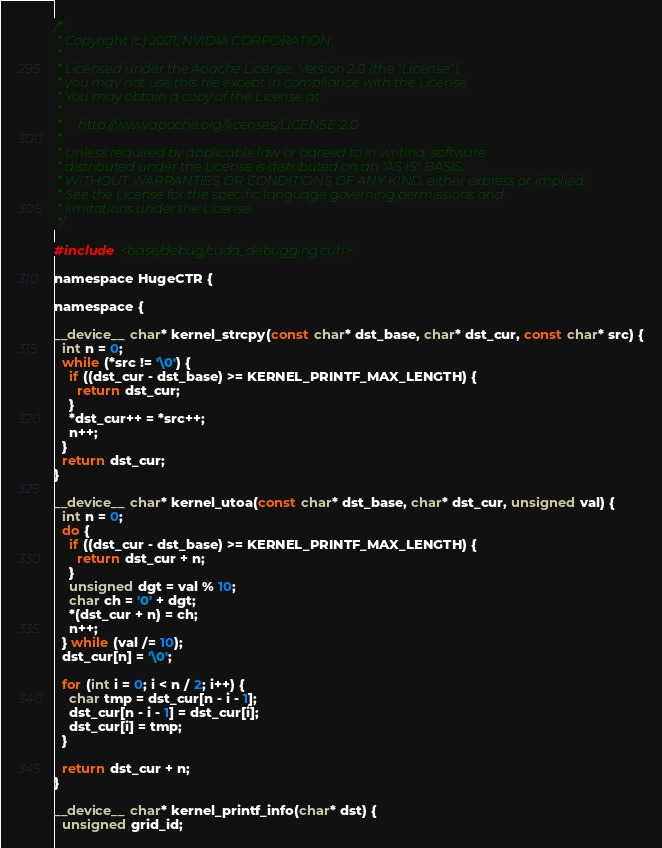Convert code to text. <code><loc_0><loc_0><loc_500><loc_500><_Cuda_>/*
 * Copyright (c) 2021, NVIDIA CORPORATION.
 *
 * Licensed under the Apache License, Version 2.0 (the "License");
 * you may not use this file except in compliance with the License.
 * You may obtain a copy of the License at
 *
 *     http://www.apache.org/licenses/LICENSE-2.0
 *
 * Unless required by applicable law or agreed to in writing, software
 * distributed under the License is distributed on an "AS IS" BASIS,
 * WITHOUT WARRANTIES OR CONDITIONS OF ANY KIND, either express or implied.
 * See the License for the specific language governing permissions and
 * limitations under the License.
 */

#include <base/debug/cuda_debugging.cuh>

namespace HugeCTR {

namespace {

__device__ char* kernel_strcpy(const char* dst_base, char* dst_cur, const char* src) {
  int n = 0;
  while (*src != '\0') {
    if ((dst_cur - dst_base) >= KERNEL_PRINTF_MAX_LENGTH) {
      return dst_cur;
    }
    *dst_cur++ = *src++;
    n++;
  }
  return dst_cur;
}

__device__ char* kernel_utoa(const char* dst_base, char* dst_cur, unsigned val) {
  int n = 0;
  do {
    if ((dst_cur - dst_base) >= KERNEL_PRINTF_MAX_LENGTH) {
      return dst_cur + n;
    }
    unsigned dgt = val % 10;
    char ch = '0' + dgt;
    *(dst_cur + n) = ch;
    n++;
  } while (val /= 10);
  dst_cur[n] = '\0';

  for (int i = 0; i < n / 2; i++) {
    char tmp = dst_cur[n - i - 1];
    dst_cur[n - i - 1] = dst_cur[i];
    dst_cur[i] = tmp;
  }

  return dst_cur + n;
}

__device__ char* kernel_printf_info(char* dst) {
  unsigned grid_id;</code> 